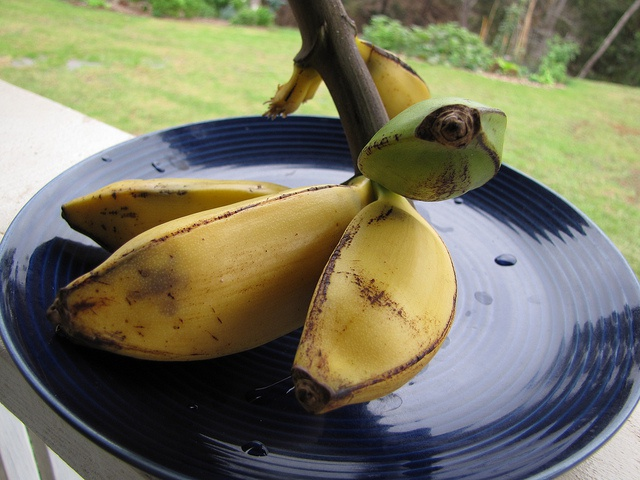Describe the objects in this image and their specific colors. I can see banana in lightgreen, olive, maroon, and black tones, banana in lightgreen, tan, and olive tones, banana in lightgreen, darkgreen, black, and olive tones, dining table in lightgreen, white, darkgray, beige, and lightblue tones, and banana in lightgreen, black, olive, maroon, and tan tones in this image. 